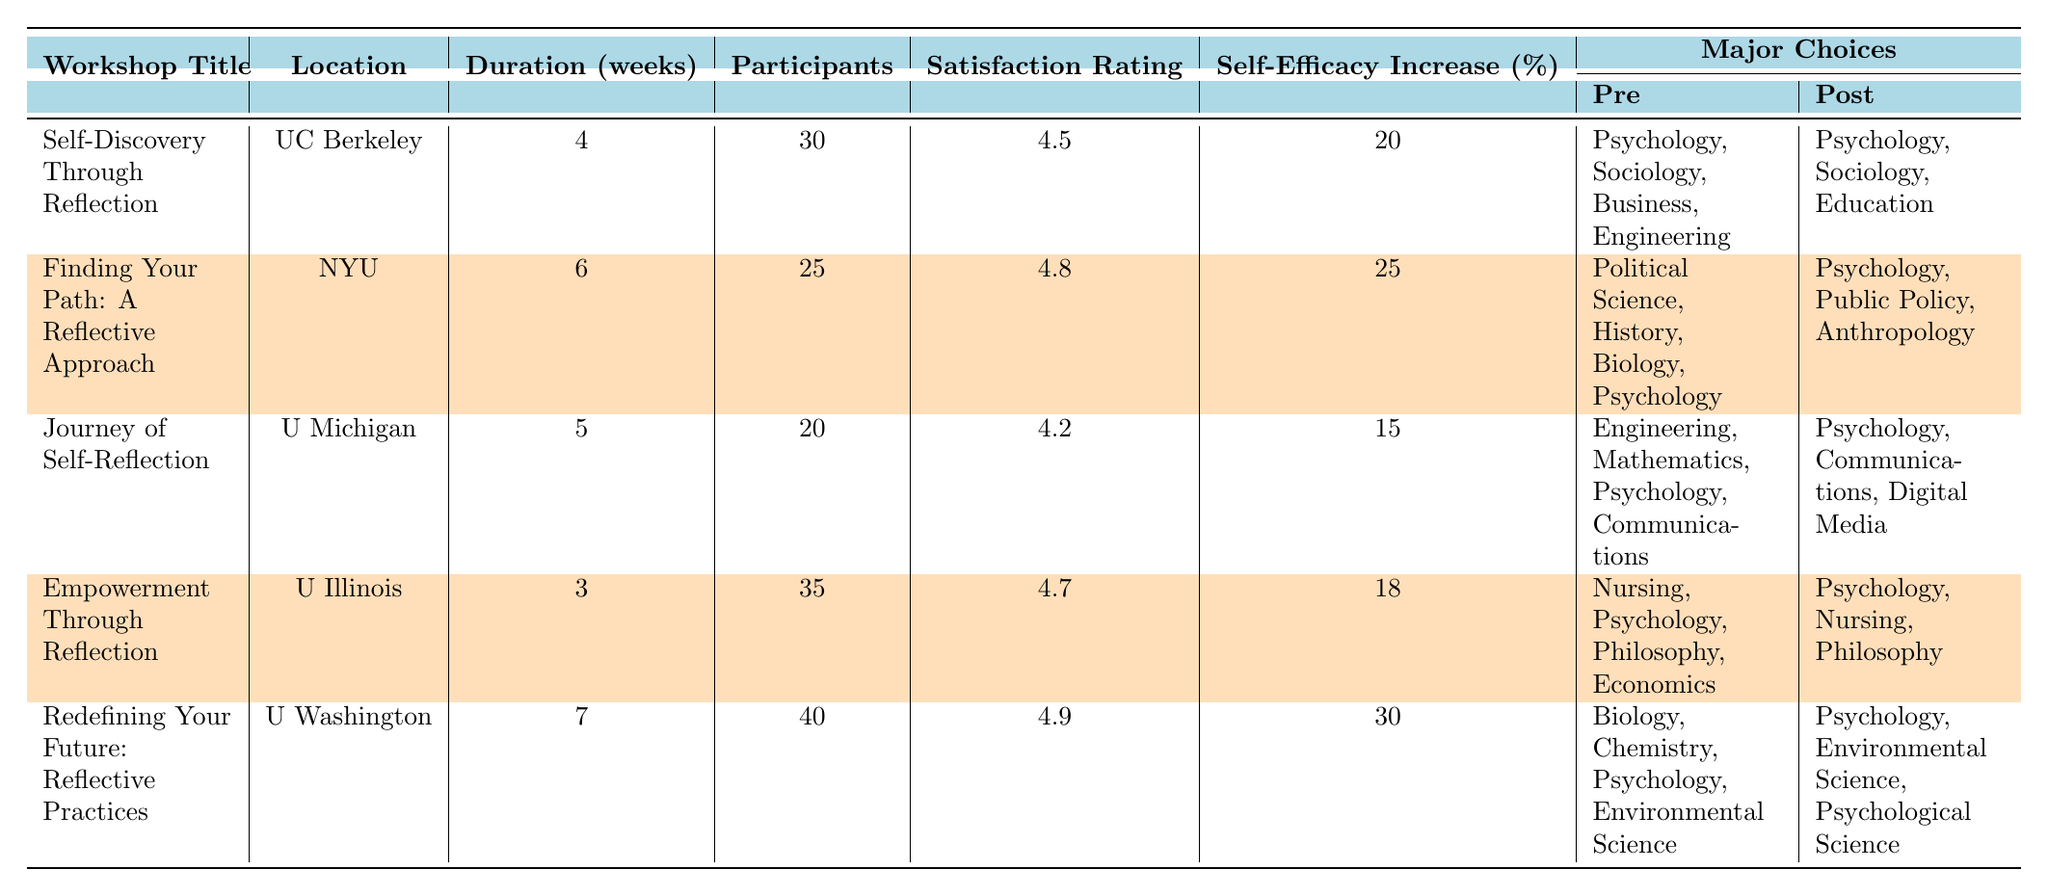What is the satisfaction rating of the workshop "Redefining Your Future: Reflective Practices"? The satisfaction rating for this workshop is listed in the table as 4.9.
Answer: 4.9 How many participants attended the "Finding Your Path: A Reflective Approach" workshop? The number of participants for this workshop is provided in the table as 25.
Answer: 25 Which workshop had the highest self-efficacy increase? By comparing the self-efficacy increase percentages in the table, "Redefining Your Future: Reflective Practices" has the highest increase at 30%.
Answer: Redefining Your Future: Reflective Practices What were the major choices for participants before attending the "Journey of Self-Reflection" workshop? The pre-major choices listed in the table for this workshop are Engineering, Mathematics, Psychology, and Communications.
Answer: Engineering, Mathematics, Psychology, Communications What is the average satisfaction rating across all workshops? The satisfaction ratings are 4.5, 4.8, 4.2, 4.7, and 4.9. To find the average, add them together (4.5 + 4.8 + 4.2 + 4.7 + 4.9 = 24.1) and divide by 5, giving an average of 4.82.
Answer: 4.82 What is the self-efficacy increase of the workshop with the lowest number of participants? The workshop with the lowest participants is "Journey of Self-Reflection" with 20 participants, and its self-efficacy increase is 15%.
Answer: 15% Did any workshop participants choose "Business" as a major after attending their workshop? By checking the post-major choices, there is no mention of "Business" in any of the workshops, indicating that no participants chose this major after the workshops.
Answer: No What percentage of participants in the "Empowerment Through Reflection" workshop changed their major choices? The major choices pre are Nursing, Psychology, Philosophy, and Economics, while the post choices include Psychology, Nursing, and Philosophy. Since this does not indicate a change in major choices but rather a reaffirmation of existing ones, the percentage is not countable.
Answer: 0% Which university hosted the workshop with the shortest duration? The shortest duration workshop listed is "Empowerment Through Reflection" at 3 weeks, hosted by the University of Illinois.
Answer: University of Illinois What were the major choices for participants after attending the "Self-Discovery Through Reflection" workshop? The post-major choices after attending this workshop are Psychology, Sociology, and Education, as indicated in the table.
Answer: Psychology, Sociology, Education How many workshops had participants who chose "Psychology" as a post-major? By reviewing the post-major choices in the table, all workshops have "Psychology" as a post-major choice; thus, there are 5 workshops.
Answer: 5 